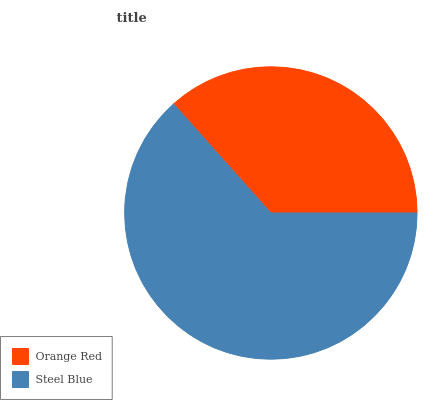Is Orange Red the minimum?
Answer yes or no. Yes. Is Steel Blue the maximum?
Answer yes or no. Yes. Is Steel Blue the minimum?
Answer yes or no. No. Is Steel Blue greater than Orange Red?
Answer yes or no. Yes. Is Orange Red less than Steel Blue?
Answer yes or no. Yes. Is Orange Red greater than Steel Blue?
Answer yes or no. No. Is Steel Blue less than Orange Red?
Answer yes or no. No. Is Steel Blue the high median?
Answer yes or no. Yes. Is Orange Red the low median?
Answer yes or no. Yes. Is Orange Red the high median?
Answer yes or no. No. Is Steel Blue the low median?
Answer yes or no. No. 